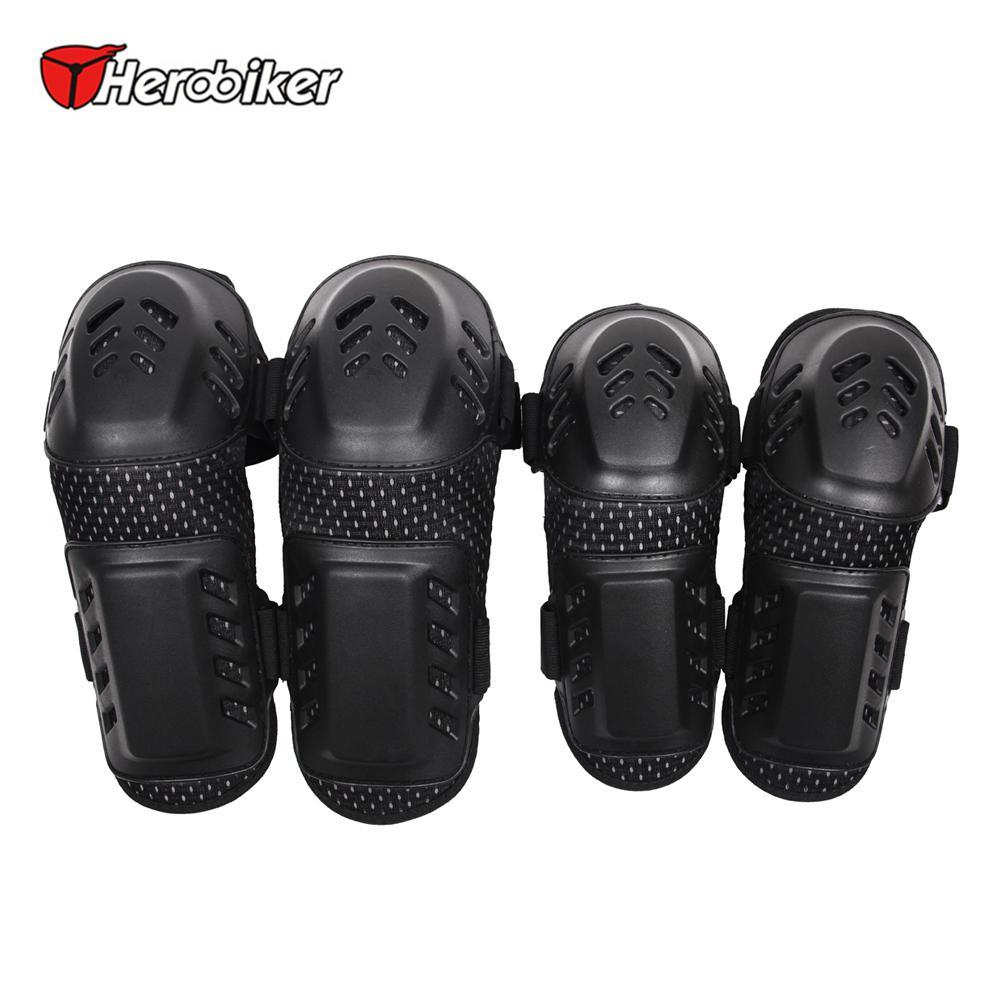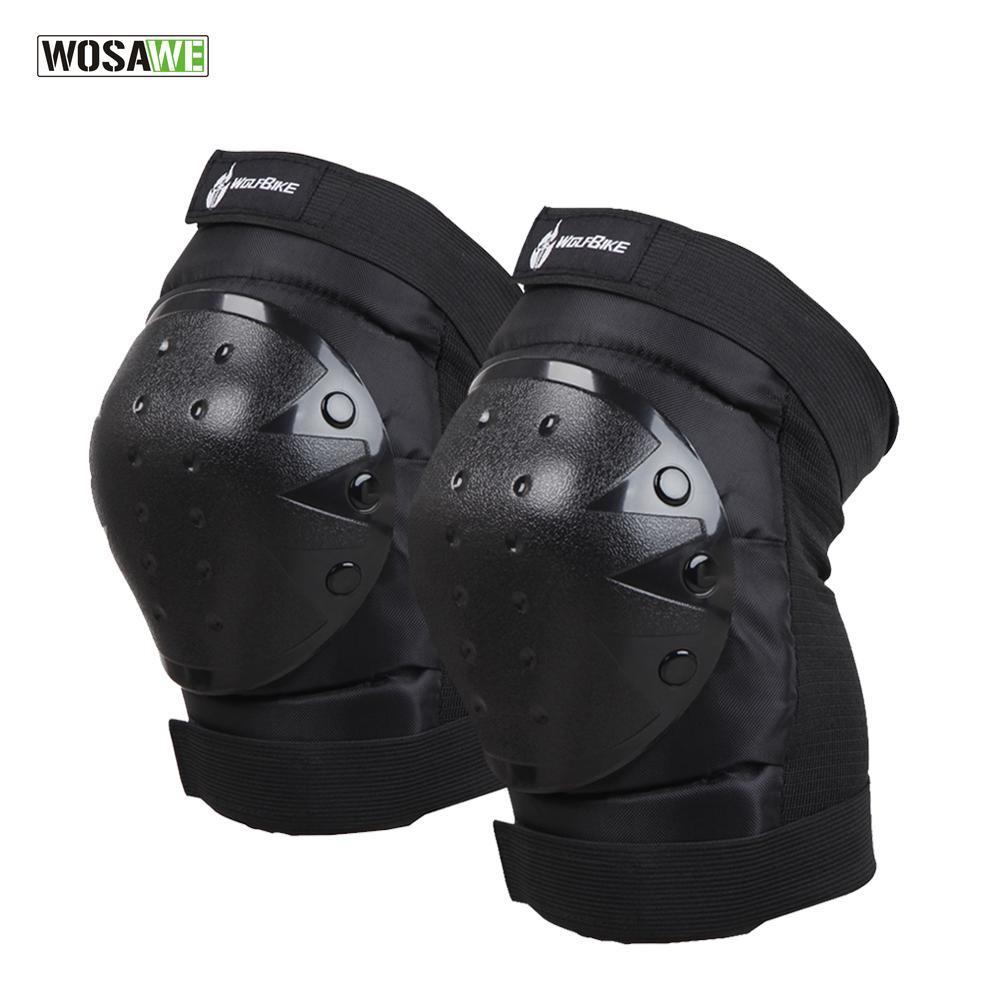The first image is the image on the left, the second image is the image on the right. Examine the images to the left and right. Is the description "One image contains just one pair of black knee pads." accurate? Answer yes or no. Yes. The first image is the image on the left, the second image is the image on the right. Assess this claim about the two images: "Exactly eight pieces of equipment are shown in groups of four each.". Correct or not? Answer yes or no. No. 